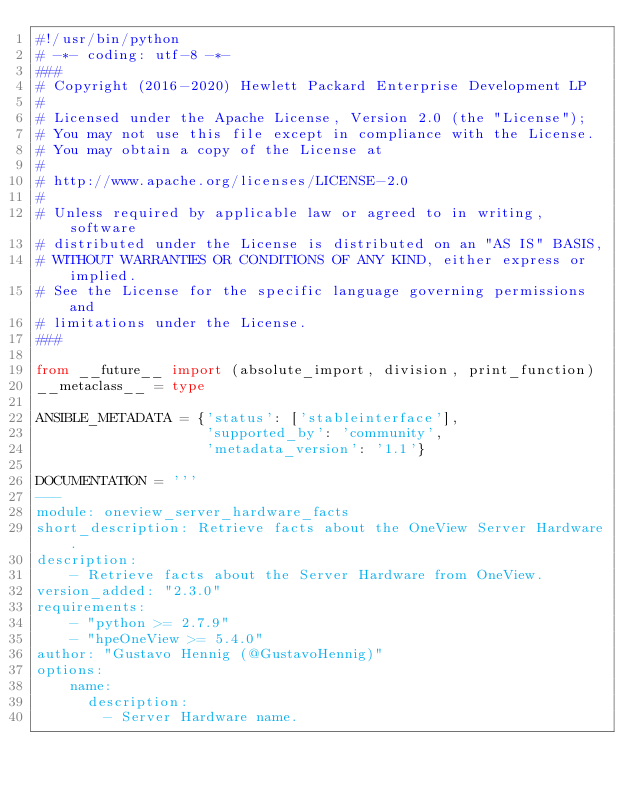<code> <loc_0><loc_0><loc_500><loc_500><_Python_>#!/usr/bin/python
# -*- coding: utf-8 -*-
###
# Copyright (2016-2020) Hewlett Packard Enterprise Development LP
#
# Licensed under the Apache License, Version 2.0 (the "License");
# You may not use this file except in compliance with the License.
# You may obtain a copy of the License at
#
# http://www.apache.org/licenses/LICENSE-2.0
#
# Unless required by applicable law or agreed to in writing, software
# distributed under the License is distributed on an "AS IS" BASIS,
# WITHOUT WARRANTIES OR CONDITIONS OF ANY KIND, either express or implied.
# See the License for the specific language governing permissions and
# limitations under the License.
###

from __future__ import (absolute_import, division, print_function)
__metaclass__ = type

ANSIBLE_METADATA = {'status': ['stableinterface'],
                    'supported_by': 'community',
                    'metadata_version': '1.1'}

DOCUMENTATION = '''
---
module: oneview_server_hardware_facts
short_description: Retrieve facts about the OneView Server Hardware.
description:
    - Retrieve facts about the Server Hardware from OneView.
version_added: "2.3.0"
requirements:
    - "python >= 2.7.9"
    - "hpeOneView >= 5.4.0"
author: "Gustavo Hennig (@GustavoHennig)"
options:
    name:
      description:
        - Server Hardware name.</code> 